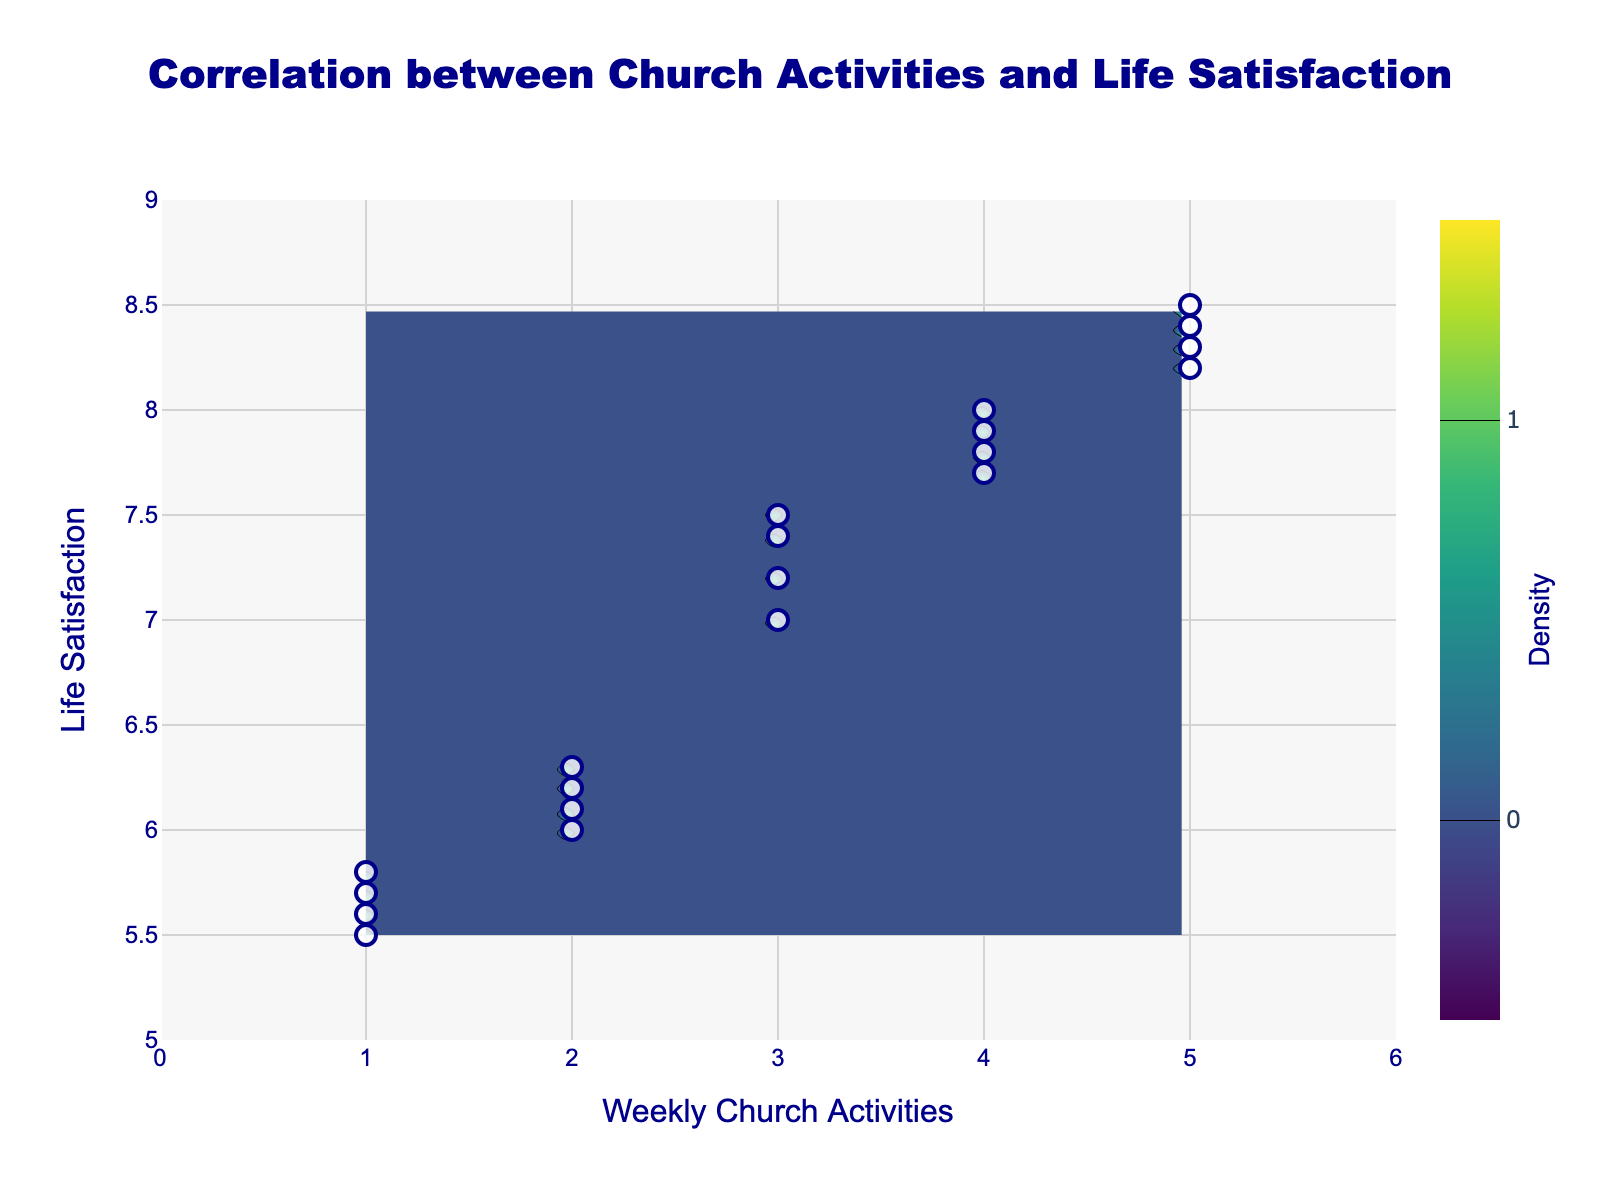What's the title of the plot? The title of the plot is displayed at the top of the figure in blue text.
Answer: Correlation between Church Activities and Life Satisfaction How many data points represent parishioners' weekly church activities and life satisfaction levels? The scatter plot markers represent the individual data points, and counting each one gives the total number of parishioners.
Answer: 20 What's the range for weekly church activities on the x-axis? The x-axis ranges from 0 to 6, as indicated by the tick marks and axis labels.
Answer: 0 to 6 Which parishioner activity frequency appears to have a higher life satisfaction on average, 1 activity per week or 5 activities per week? By observing the scatter plot, points around 1 activity per week cluster in the lower life satisfaction range, whereas those around 5 activities per week cluster higher.
Answer: 5 activities per week Describe the color scale used in the contour plot. The contour plot uses the 'Viridis' color scale, transitioning from dark green (low density) to bright yellow (high density).
Answer: Viridis What is the range for life satisfaction on the y-axis? The y-axis ranges from 5 to 9, as indicated by the tick marks and axis labels.
Answer: 5 to 9 Which area has the highest density of data points? In the contour plot, the brightest yellow region represents the highest density, which appears around 3-5 weekly activities and a life satisfaction of 7.5-8.5.
Answer: Around 3-5 weekly activities and 7.5-8.5 life satisfaction Is there a visible correlation between weekly church activities and life satisfaction? The scatter plot and contour lines show that as weekly church activities increase, life satisfaction also tends to increase, suggesting a positive correlation.
Answer: Yes Which life satisfaction level has the most parishioners? The scatter plot reveals most data points clustering around life satisfaction levels between 7 and 8.5.
Answer: 7 to 8.5 Are there more parishioners who are less active (1-2 activities per week) or more active (4-5 activities per week)? Observing the scatter plot, it seems that there are more data points in the range of 4-5 activities per week compared to 1-2 activities per week.
Answer: More active (4-5 activities per week) 